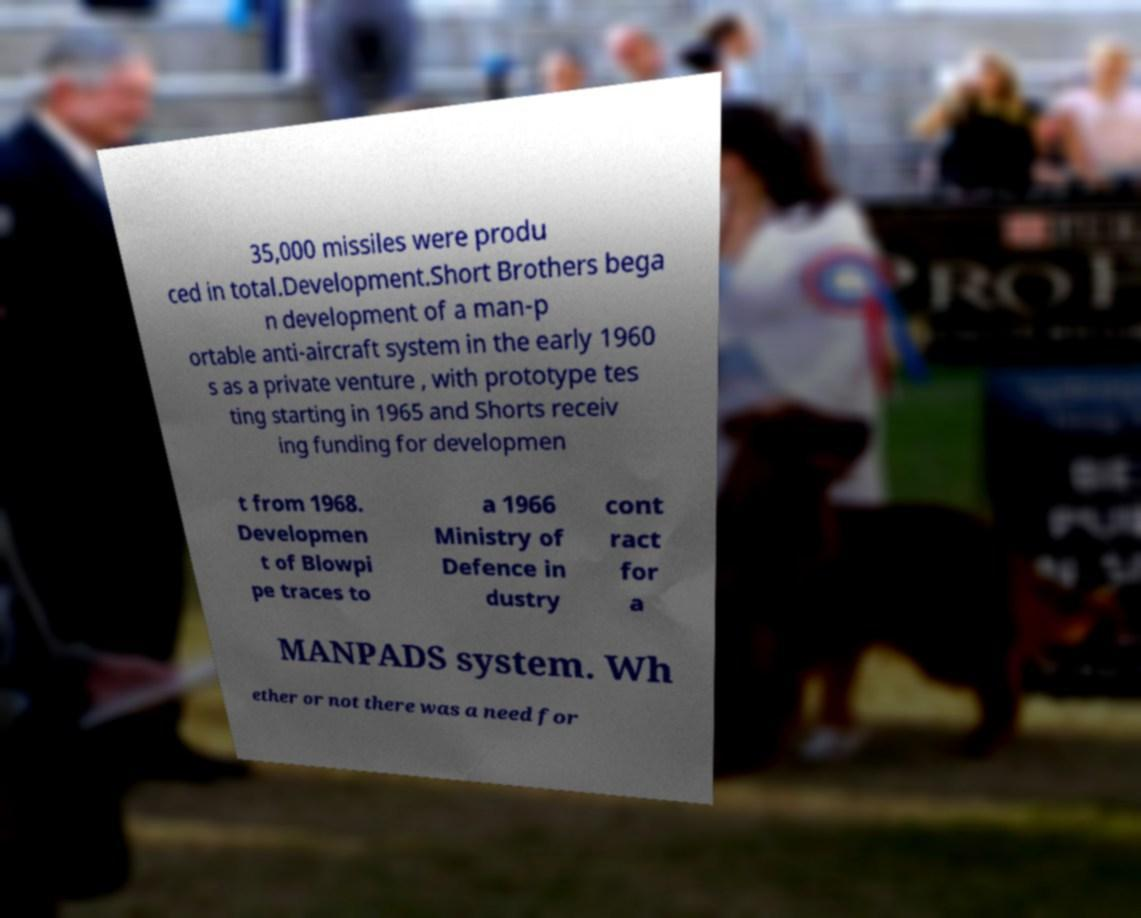Please identify and transcribe the text found in this image. 35,000 missiles were produ ced in total.Development.Short Brothers bega n development of a man-p ortable anti-aircraft system in the early 1960 s as a private venture , with prototype tes ting starting in 1965 and Shorts receiv ing funding for developmen t from 1968. Developmen t of Blowpi pe traces to a 1966 Ministry of Defence in dustry cont ract for a MANPADS system. Wh ether or not there was a need for 